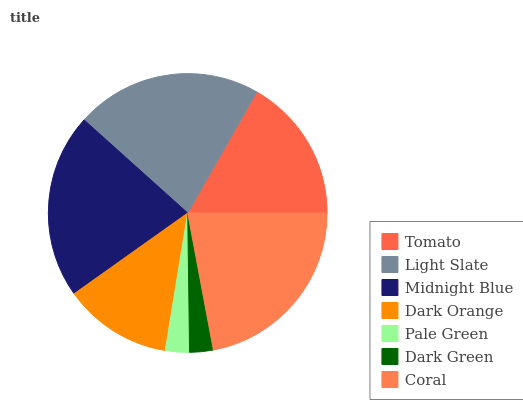Is Dark Green the minimum?
Answer yes or no. Yes. Is Coral the maximum?
Answer yes or no. Yes. Is Light Slate the minimum?
Answer yes or no. No. Is Light Slate the maximum?
Answer yes or no. No. Is Light Slate greater than Tomato?
Answer yes or no. Yes. Is Tomato less than Light Slate?
Answer yes or no. Yes. Is Tomato greater than Light Slate?
Answer yes or no. No. Is Light Slate less than Tomato?
Answer yes or no. No. Is Tomato the high median?
Answer yes or no. Yes. Is Tomato the low median?
Answer yes or no. Yes. Is Light Slate the high median?
Answer yes or no. No. Is Dark Orange the low median?
Answer yes or no. No. 